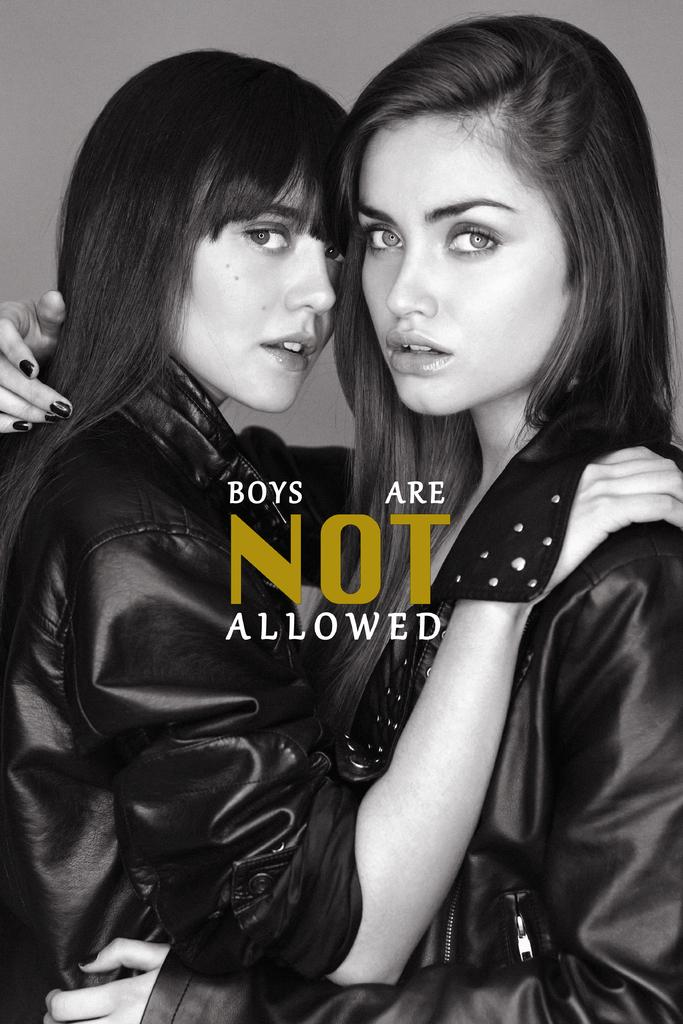How many people are in the image? There are two women in the image. What are the women wearing? The women are wearing black dresses. Can you describe any additional features of the image? There is a watermark in the center of the image. What type of texture can be seen on the cats in the image? There are no cats present in the image, so it is not possible to determine their texture. 